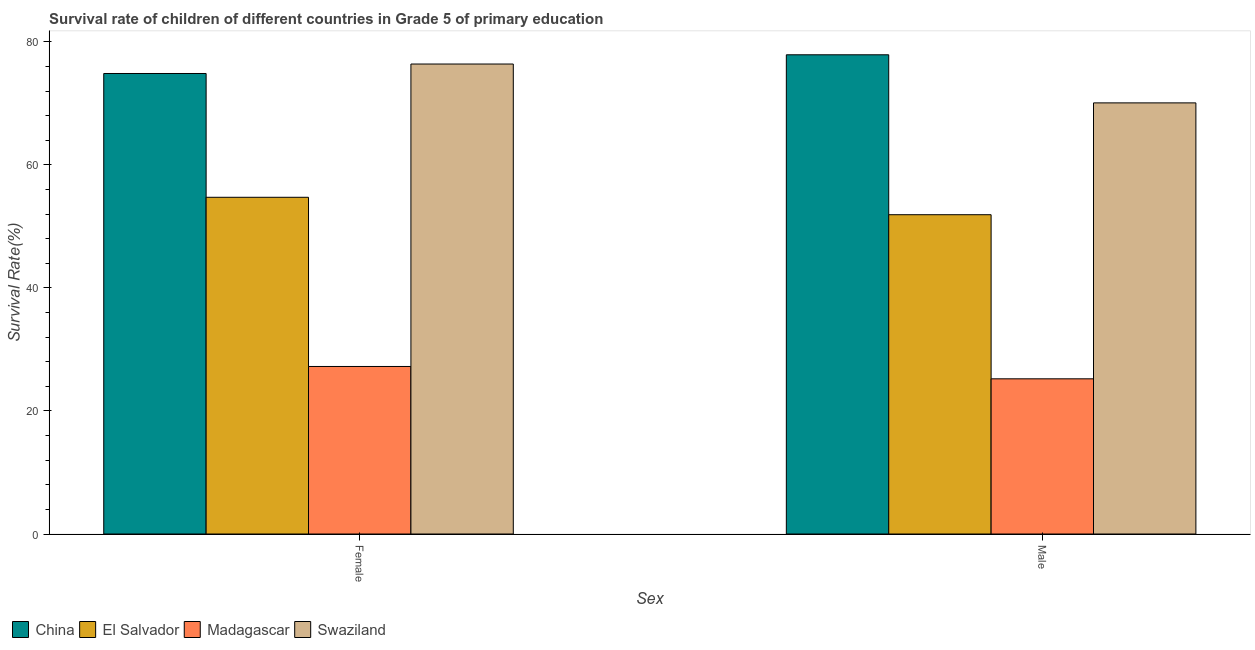What is the label of the 1st group of bars from the left?
Ensure brevity in your answer.  Female. What is the survival rate of male students in primary education in El Salvador?
Your answer should be very brief. 51.89. Across all countries, what is the maximum survival rate of male students in primary education?
Ensure brevity in your answer.  77.89. Across all countries, what is the minimum survival rate of male students in primary education?
Make the answer very short. 25.22. In which country was the survival rate of female students in primary education maximum?
Make the answer very short. Swaziland. In which country was the survival rate of female students in primary education minimum?
Offer a very short reply. Madagascar. What is the total survival rate of female students in primary education in the graph?
Offer a terse response. 233.18. What is the difference between the survival rate of female students in primary education in Madagascar and that in Swaziland?
Ensure brevity in your answer.  -49.16. What is the difference between the survival rate of male students in primary education in El Salvador and the survival rate of female students in primary education in China?
Your response must be concise. -22.95. What is the average survival rate of female students in primary education per country?
Make the answer very short. 58.3. What is the difference between the survival rate of male students in primary education and survival rate of female students in primary education in Swaziland?
Your answer should be compact. -6.32. What is the ratio of the survival rate of male students in primary education in Madagascar to that in China?
Provide a short and direct response. 0.32. In how many countries, is the survival rate of female students in primary education greater than the average survival rate of female students in primary education taken over all countries?
Provide a short and direct response. 2. What does the 3rd bar from the left in Female represents?
Ensure brevity in your answer.  Madagascar. What does the 4th bar from the right in Male represents?
Offer a very short reply. China. How many bars are there?
Give a very brief answer. 8. Are all the bars in the graph horizontal?
Give a very brief answer. No. How many countries are there in the graph?
Your answer should be very brief. 4. Are the values on the major ticks of Y-axis written in scientific E-notation?
Provide a succinct answer. No. Does the graph contain any zero values?
Offer a very short reply. No. Does the graph contain grids?
Offer a terse response. No. How many legend labels are there?
Offer a terse response. 4. What is the title of the graph?
Your answer should be compact. Survival rate of children of different countries in Grade 5 of primary education. Does "Tajikistan" appear as one of the legend labels in the graph?
Your answer should be very brief. No. What is the label or title of the X-axis?
Your answer should be very brief. Sex. What is the label or title of the Y-axis?
Make the answer very short. Survival Rate(%). What is the Survival Rate(%) in China in Female?
Make the answer very short. 74.84. What is the Survival Rate(%) in El Salvador in Female?
Give a very brief answer. 54.72. What is the Survival Rate(%) in Madagascar in Female?
Provide a succinct answer. 27.23. What is the Survival Rate(%) of Swaziland in Female?
Your answer should be compact. 76.38. What is the Survival Rate(%) in China in Male?
Your answer should be very brief. 77.89. What is the Survival Rate(%) of El Salvador in Male?
Provide a succinct answer. 51.89. What is the Survival Rate(%) of Madagascar in Male?
Your answer should be very brief. 25.22. What is the Survival Rate(%) of Swaziland in Male?
Provide a succinct answer. 70.07. Across all Sex, what is the maximum Survival Rate(%) of China?
Your answer should be compact. 77.89. Across all Sex, what is the maximum Survival Rate(%) in El Salvador?
Offer a terse response. 54.72. Across all Sex, what is the maximum Survival Rate(%) of Madagascar?
Provide a short and direct response. 27.23. Across all Sex, what is the maximum Survival Rate(%) of Swaziland?
Give a very brief answer. 76.38. Across all Sex, what is the minimum Survival Rate(%) in China?
Keep it short and to the point. 74.84. Across all Sex, what is the minimum Survival Rate(%) of El Salvador?
Give a very brief answer. 51.89. Across all Sex, what is the minimum Survival Rate(%) in Madagascar?
Provide a succinct answer. 25.22. Across all Sex, what is the minimum Survival Rate(%) in Swaziland?
Provide a short and direct response. 70.07. What is the total Survival Rate(%) in China in the graph?
Provide a short and direct response. 152.73. What is the total Survival Rate(%) in El Salvador in the graph?
Provide a short and direct response. 106.62. What is the total Survival Rate(%) in Madagascar in the graph?
Keep it short and to the point. 52.45. What is the total Survival Rate(%) in Swaziland in the graph?
Offer a terse response. 146.45. What is the difference between the Survival Rate(%) of China in Female and that in Male?
Your answer should be very brief. -3.04. What is the difference between the Survival Rate(%) in El Salvador in Female and that in Male?
Your answer should be compact. 2.83. What is the difference between the Survival Rate(%) of Madagascar in Female and that in Male?
Offer a very short reply. 2.01. What is the difference between the Survival Rate(%) of Swaziland in Female and that in Male?
Provide a short and direct response. 6.32. What is the difference between the Survival Rate(%) of China in Female and the Survival Rate(%) of El Salvador in Male?
Offer a very short reply. 22.95. What is the difference between the Survival Rate(%) of China in Female and the Survival Rate(%) of Madagascar in Male?
Offer a very short reply. 49.62. What is the difference between the Survival Rate(%) in China in Female and the Survival Rate(%) in Swaziland in Male?
Keep it short and to the point. 4.78. What is the difference between the Survival Rate(%) in El Salvador in Female and the Survival Rate(%) in Madagascar in Male?
Provide a succinct answer. 29.5. What is the difference between the Survival Rate(%) in El Salvador in Female and the Survival Rate(%) in Swaziland in Male?
Your answer should be compact. -15.34. What is the difference between the Survival Rate(%) in Madagascar in Female and the Survival Rate(%) in Swaziland in Male?
Provide a short and direct response. -42.84. What is the average Survival Rate(%) of China per Sex?
Offer a very short reply. 76.37. What is the average Survival Rate(%) of El Salvador per Sex?
Keep it short and to the point. 53.31. What is the average Survival Rate(%) in Madagascar per Sex?
Keep it short and to the point. 26.23. What is the average Survival Rate(%) in Swaziland per Sex?
Provide a succinct answer. 73.23. What is the difference between the Survival Rate(%) in China and Survival Rate(%) in El Salvador in Female?
Offer a very short reply. 20.12. What is the difference between the Survival Rate(%) of China and Survival Rate(%) of Madagascar in Female?
Provide a succinct answer. 47.62. What is the difference between the Survival Rate(%) of China and Survival Rate(%) of Swaziland in Female?
Provide a succinct answer. -1.54. What is the difference between the Survival Rate(%) of El Salvador and Survival Rate(%) of Madagascar in Female?
Your response must be concise. 27.5. What is the difference between the Survival Rate(%) of El Salvador and Survival Rate(%) of Swaziland in Female?
Provide a short and direct response. -21.66. What is the difference between the Survival Rate(%) of Madagascar and Survival Rate(%) of Swaziland in Female?
Give a very brief answer. -49.16. What is the difference between the Survival Rate(%) of China and Survival Rate(%) of El Salvador in Male?
Make the answer very short. 25.99. What is the difference between the Survival Rate(%) in China and Survival Rate(%) in Madagascar in Male?
Your response must be concise. 52.66. What is the difference between the Survival Rate(%) of China and Survival Rate(%) of Swaziland in Male?
Your response must be concise. 7.82. What is the difference between the Survival Rate(%) of El Salvador and Survival Rate(%) of Madagascar in Male?
Give a very brief answer. 26.67. What is the difference between the Survival Rate(%) in El Salvador and Survival Rate(%) in Swaziland in Male?
Your answer should be very brief. -18.17. What is the difference between the Survival Rate(%) of Madagascar and Survival Rate(%) of Swaziland in Male?
Provide a succinct answer. -44.85. What is the ratio of the Survival Rate(%) in China in Female to that in Male?
Give a very brief answer. 0.96. What is the ratio of the Survival Rate(%) in El Salvador in Female to that in Male?
Keep it short and to the point. 1.05. What is the ratio of the Survival Rate(%) of Madagascar in Female to that in Male?
Your answer should be very brief. 1.08. What is the ratio of the Survival Rate(%) in Swaziland in Female to that in Male?
Your answer should be very brief. 1.09. What is the difference between the highest and the second highest Survival Rate(%) of China?
Ensure brevity in your answer.  3.04. What is the difference between the highest and the second highest Survival Rate(%) of El Salvador?
Your answer should be very brief. 2.83. What is the difference between the highest and the second highest Survival Rate(%) of Madagascar?
Provide a short and direct response. 2.01. What is the difference between the highest and the second highest Survival Rate(%) in Swaziland?
Make the answer very short. 6.32. What is the difference between the highest and the lowest Survival Rate(%) of China?
Your answer should be compact. 3.04. What is the difference between the highest and the lowest Survival Rate(%) of El Salvador?
Keep it short and to the point. 2.83. What is the difference between the highest and the lowest Survival Rate(%) in Madagascar?
Keep it short and to the point. 2.01. What is the difference between the highest and the lowest Survival Rate(%) of Swaziland?
Give a very brief answer. 6.32. 